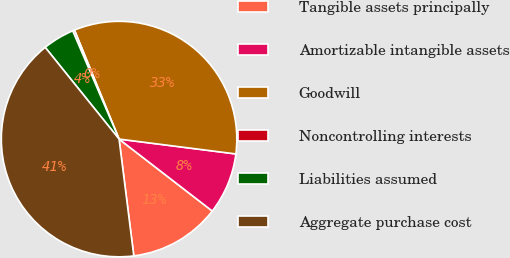Convert chart. <chart><loc_0><loc_0><loc_500><loc_500><pie_chart><fcel>Tangible assets principally<fcel>Amortizable intangible assets<fcel>Goodwill<fcel>Noncontrolling interests<fcel>Liabilities assumed<fcel>Aggregate purchase cost<nl><fcel>12.54%<fcel>8.45%<fcel>33.2%<fcel>0.26%<fcel>4.35%<fcel>41.21%<nl></chart> 